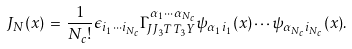Convert formula to latex. <formula><loc_0><loc_0><loc_500><loc_500>J _ { N } ( x ) \, = \, \frac { 1 } { N _ { c } ! } \epsilon _ { i _ { 1 } \cdots i _ { N _ { c } } } \Gamma ^ { \alpha _ { 1 } \cdots \alpha _ { N _ { c } } } _ { J J _ { 3 } T T _ { 3 } Y } \psi _ { \alpha _ { 1 } i _ { 1 } } ( x ) \cdots \psi _ { \alpha _ { N _ { c } } i _ { N _ { c } } } ( x ) .</formula> 